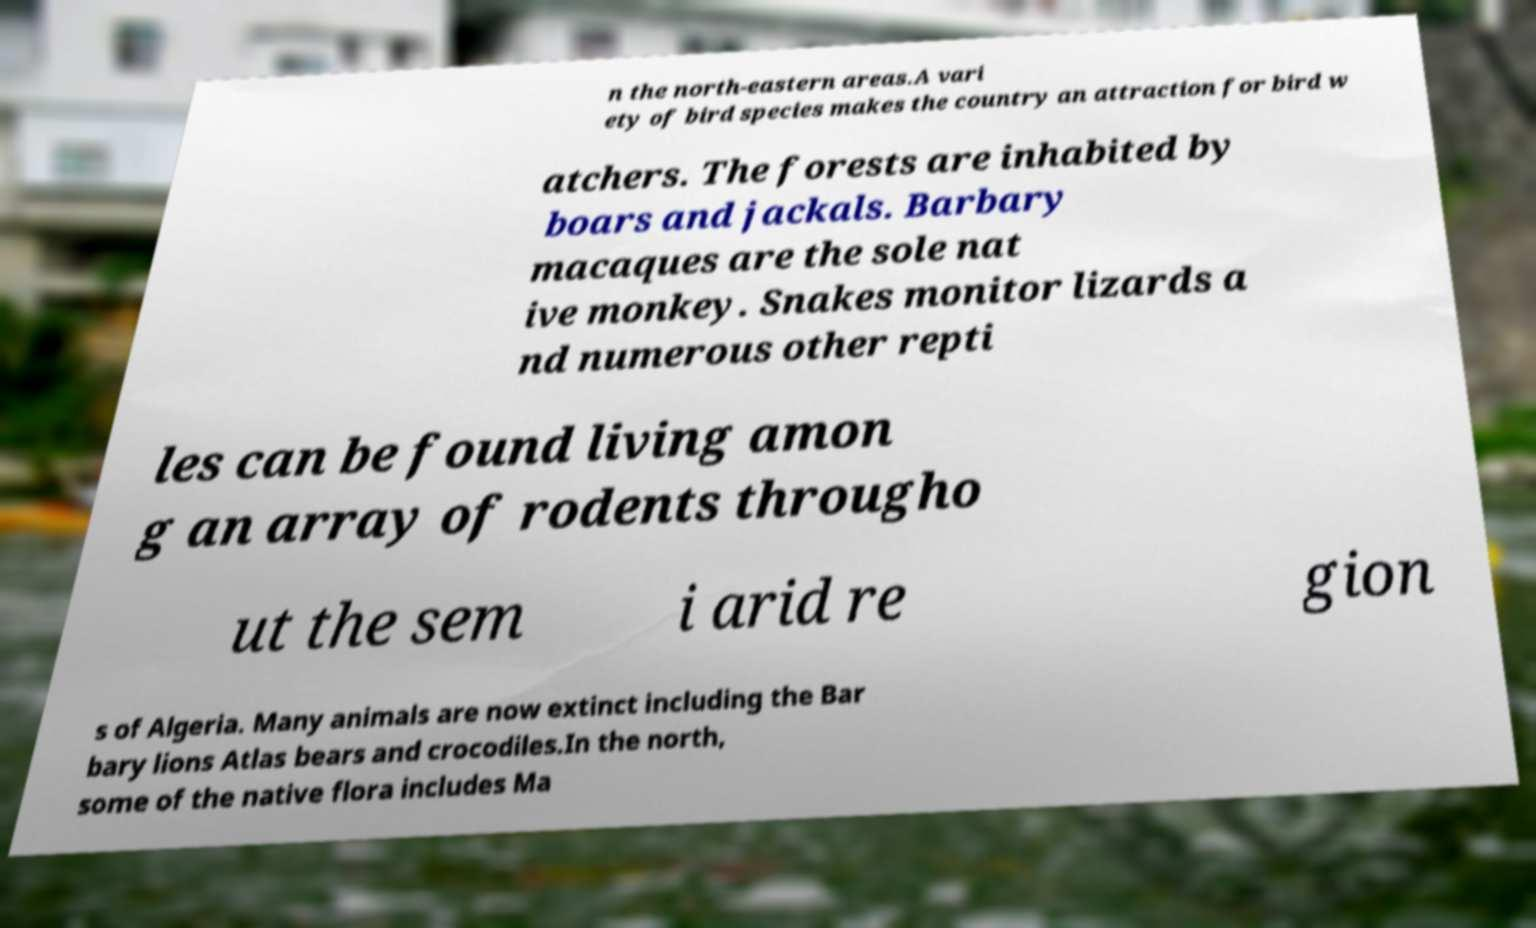I need the written content from this picture converted into text. Can you do that? n the north-eastern areas.A vari ety of bird species makes the country an attraction for bird w atchers. The forests are inhabited by boars and jackals. Barbary macaques are the sole nat ive monkey. Snakes monitor lizards a nd numerous other repti les can be found living amon g an array of rodents througho ut the sem i arid re gion s of Algeria. Many animals are now extinct including the Bar bary lions Atlas bears and crocodiles.In the north, some of the native flora includes Ma 